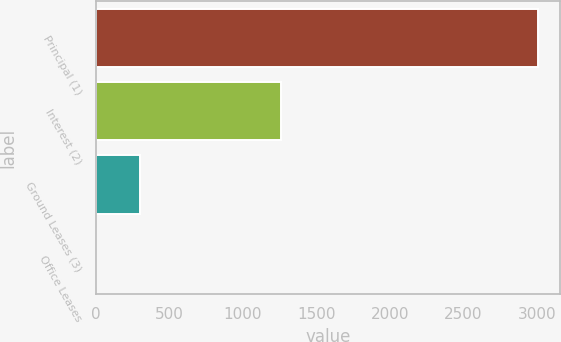Convert chart to OTSL. <chart><loc_0><loc_0><loc_500><loc_500><bar_chart><fcel>Principal (1)<fcel>Interest (2)<fcel>Ground Leases (3)<fcel>Office Leases<nl><fcel>3008.3<fcel>1260.3<fcel>301.1<fcel>0.3<nl></chart> 